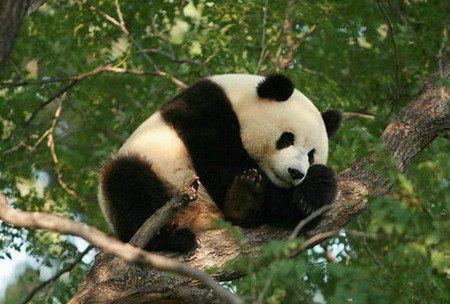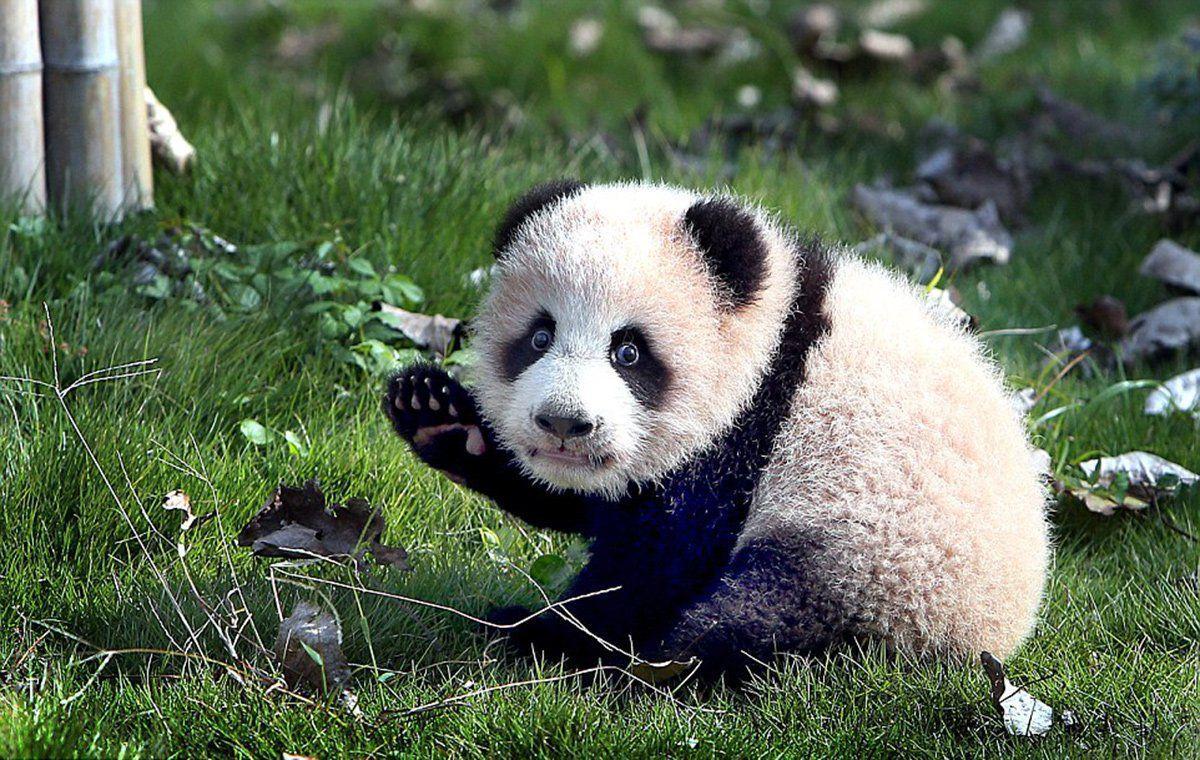The first image is the image on the left, the second image is the image on the right. Analyze the images presented: Is the assertion "One image contains twice as many pandas as the other image and features two pandas facing generally toward each other." valid? Answer yes or no. No. The first image is the image on the left, the second image is the image on the right. Assess this claim about the two images: "There are at most two panda bears.". Correct or not? Answer yes or no. Yes. 